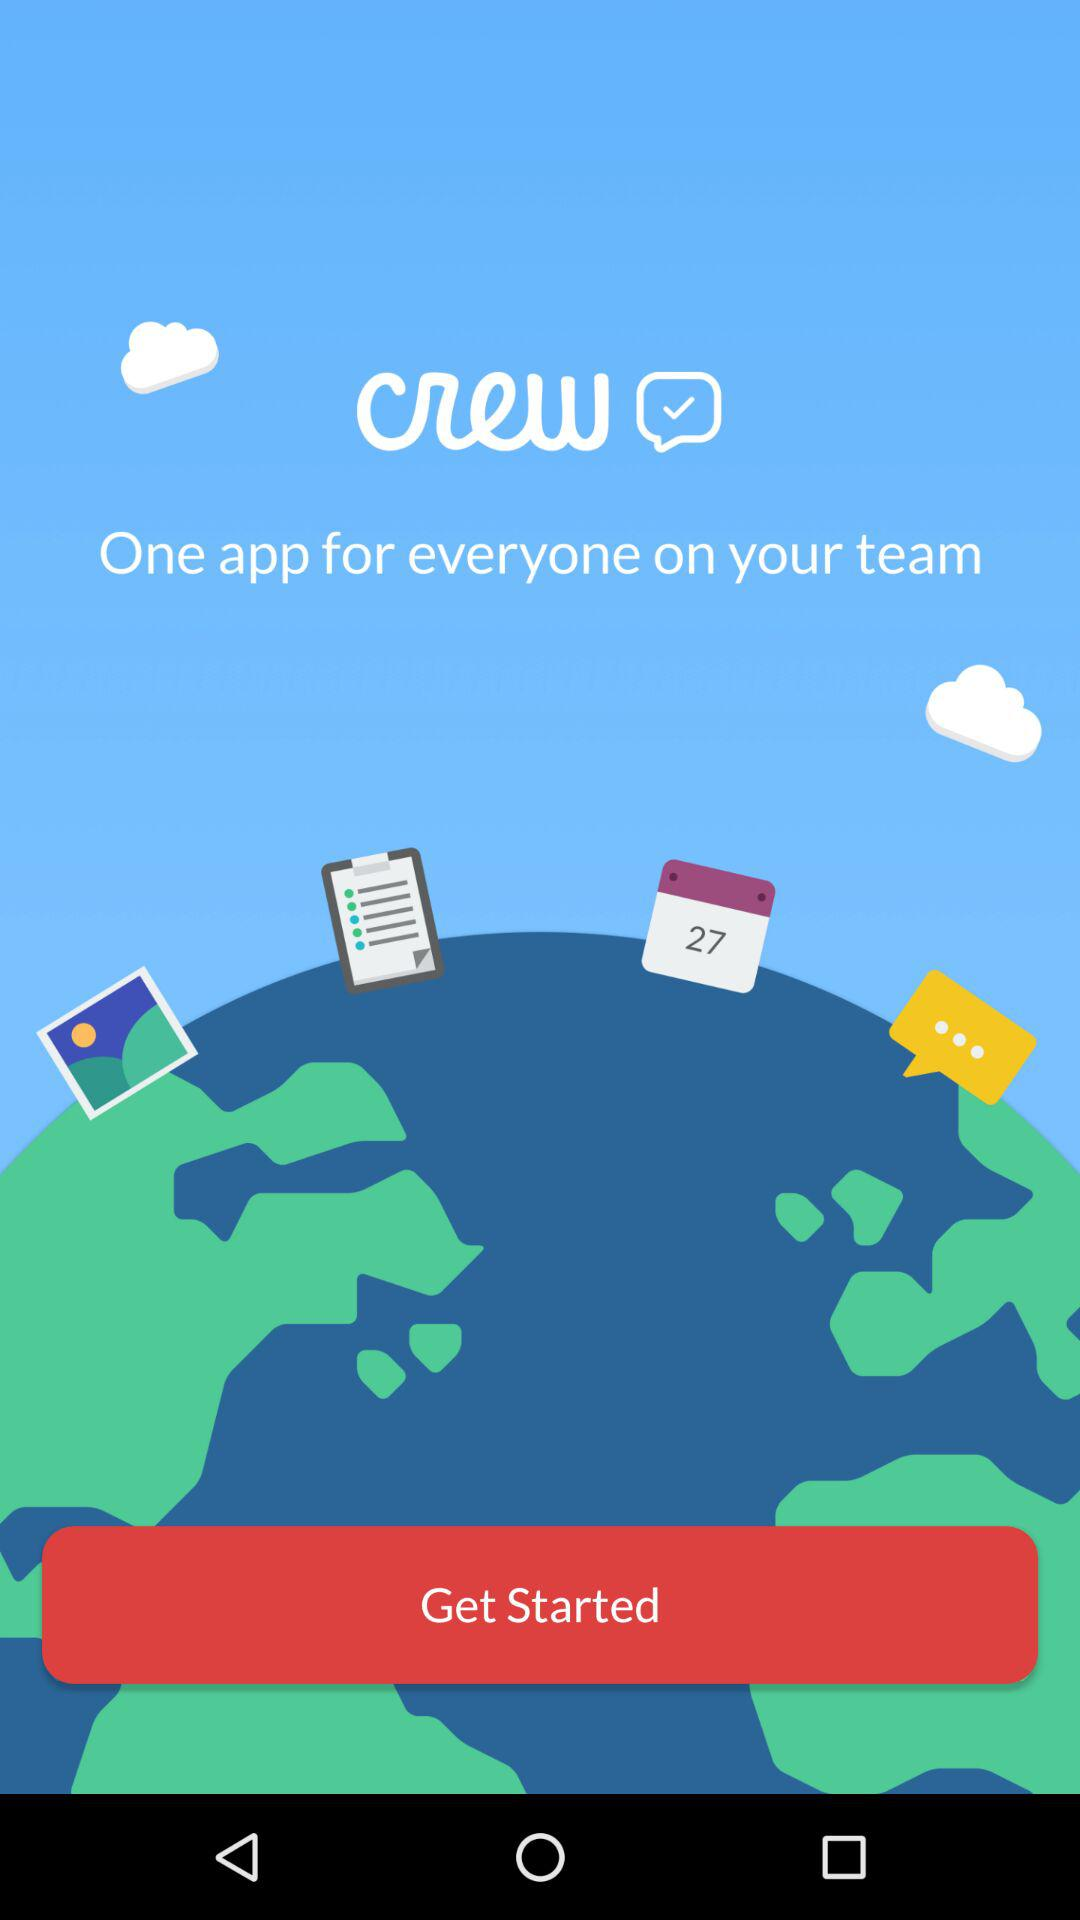What is the application name? The application name is "crew". 